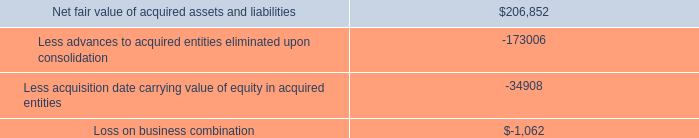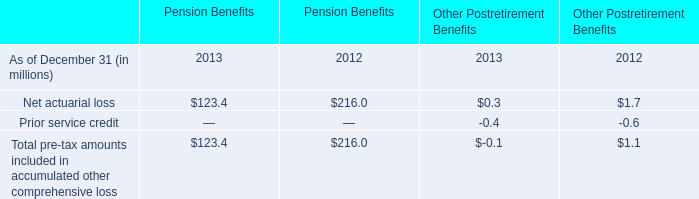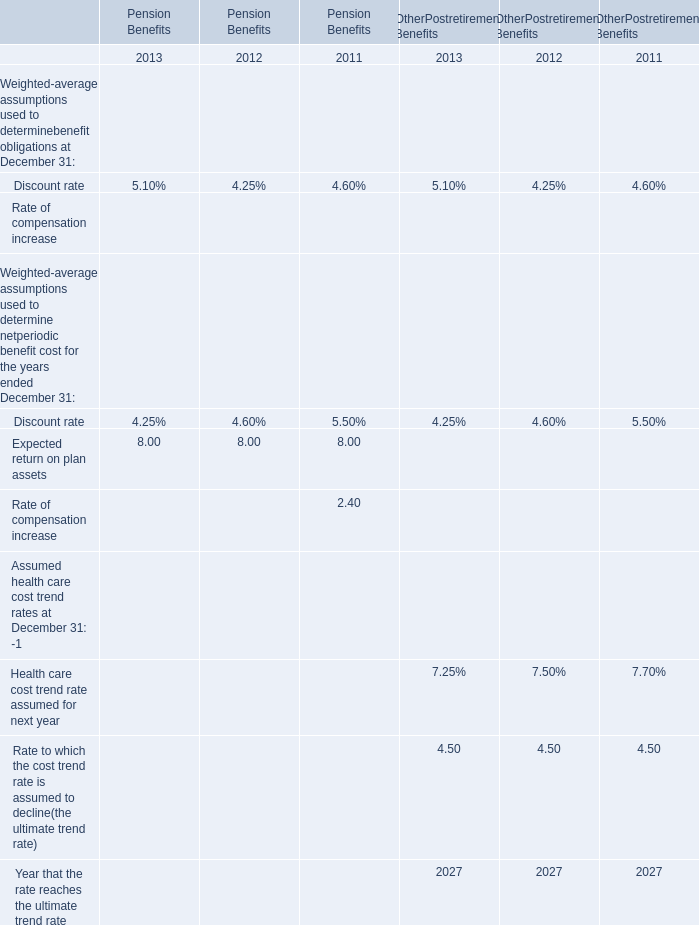How many years does the Net actuarial loss for Pension Benefits stay higher than the Net actuarial loss for Other Postretirement Benefits? 
Answer: 2. 